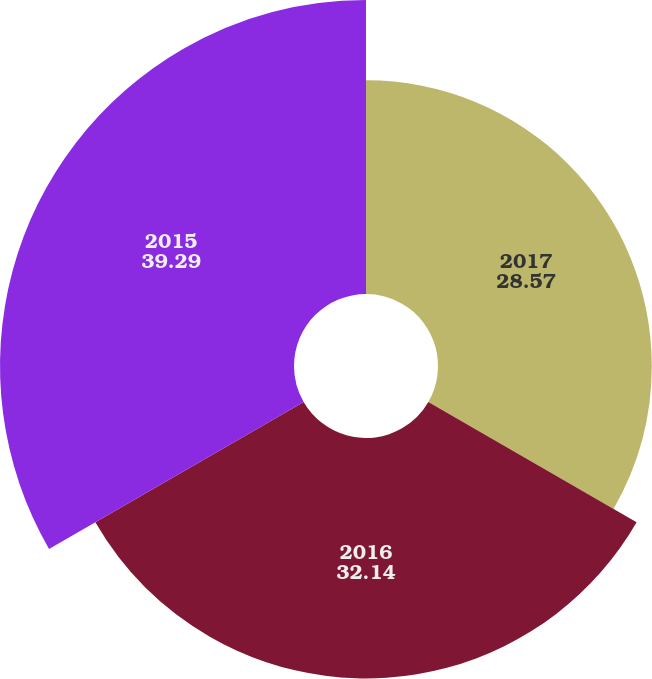<chart> <loc_0><loc_0><loc_500><loc_500><pie_chart><fcel>2017<fcel>2016<fcel>2015<nl><fcel>28.57%<fcel>32.14%<fcel>39.29%<nl></chart> 